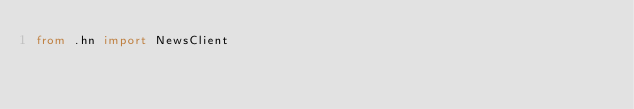<code> <loc_0><loc_0><loc_500><loc_500><_Python_>from .hn import NewsClient</code> 